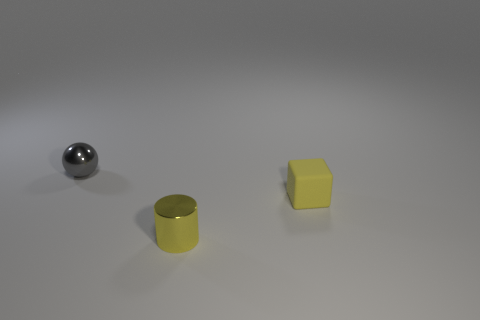Add 2 tiny rubber objects. How many objects exist? 5 Subtract all blocks. How many objects are left? 2 Subtract 0 brown cylinders. How many objects are left? 3 Subtract all brown cylinders. Subtract all purple spheres. How many cylinders are left? 1 Subtract all yellow cylinders. Subtract all large brown cylinders. How many objects are left? 2 Add 3 small gray metal balls. How many small gray metal balls are left? 4 Add 1 cylinders. How many cylinders exist? 2 